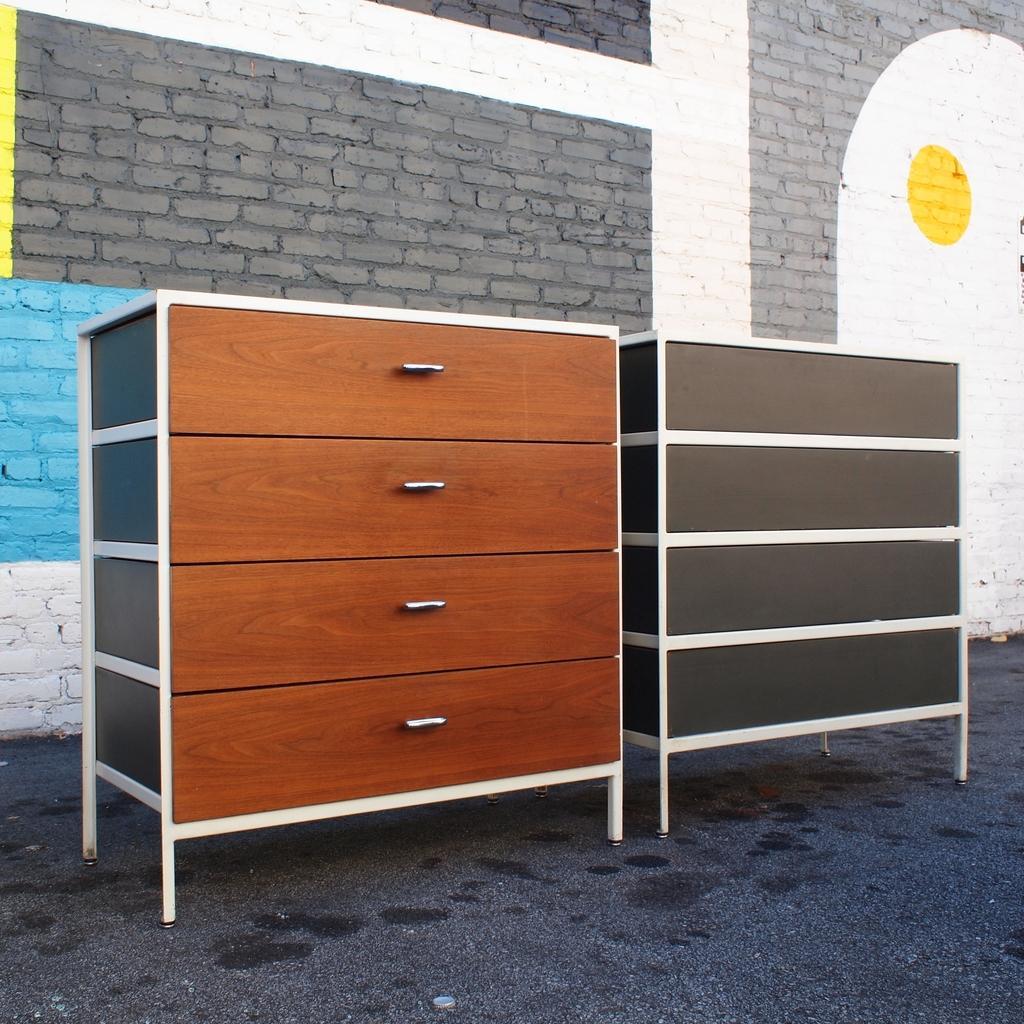Please provide a concise description of this image. In the front of the image there are cupboards. In the background of the image there is a wall. Painting is on the wall. 